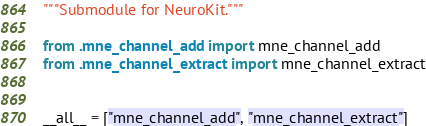<code> <loc_0><loc_0><loc_500><loc_500><_Python_>"""Submodule for NeuroKit."""

from .mne_channel_add import mne_channel_add
from .mne_channel_extract import mne_channel_extract


__all__ = ["mne_channel_add", "mne_channel_extract"]
</code> 